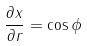<formula> <loc_0><loc_0><loc_500><loc_500>\frac { \partial x } { \partial r } = \cos \phi</formula> 